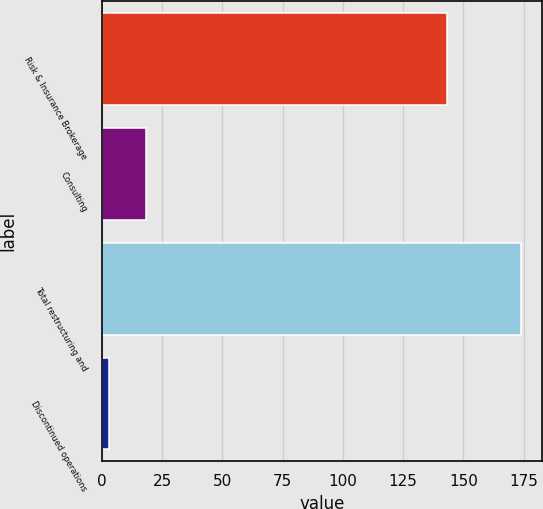Convert chart. <chart><loc_0><loc_0><loc_500><loc_500><bar_chart><fcel>Risk & Insurance Brokerage<fcel>Consulting<fcel>Total restructuring and<fcel>Discontinued operations<nl><fcel>143<fcel>18.5<fcel>174<fcel>3<nl></chart> 